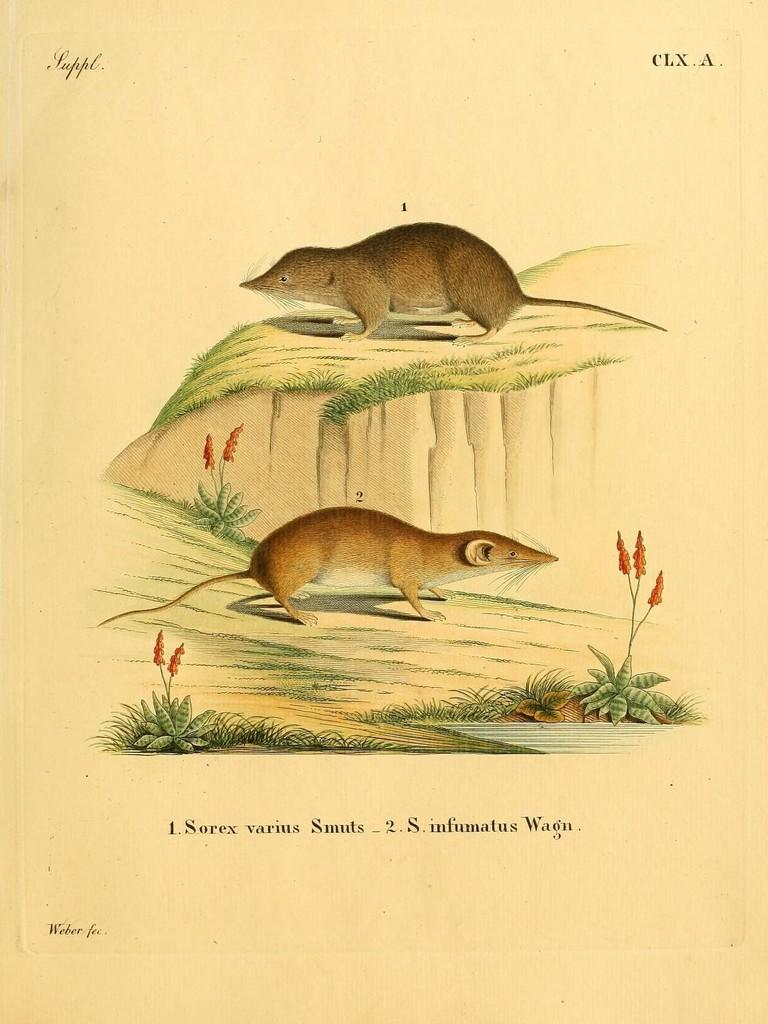What type of poster is in the image? There is a cartoon poster in the image. What animals are present in the image? There are two rats standing on the ground in the image. What type of vegetation is in the image? There are flowers on a plant in the image. What can be read on the poster in the image? There is text written on the poster in the image. What type of bird is perched on the lock in the image? There is no bird or lock present in the image. 